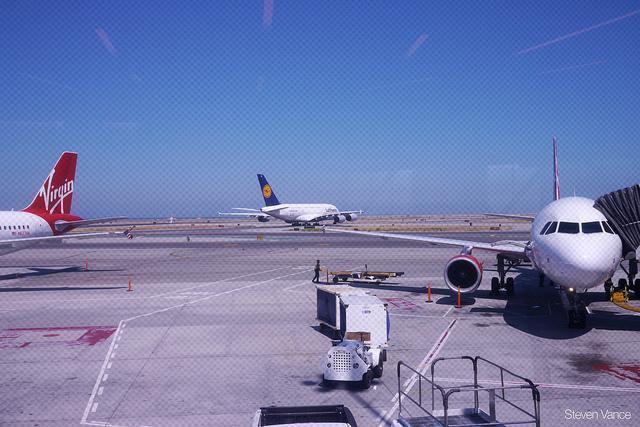Who owns the vehicle on the left?
Choose the right answer from the provided options to respond to the question.
Options: Lufthansa, delta, virgin atlantic, united airlines. Virgin atlantic. What color is the tail fin on the furthest left side of the tarmac?
Select the accurate response from the four choices given to answer the question.
Options: Red, blue, yellow, green. Red. 